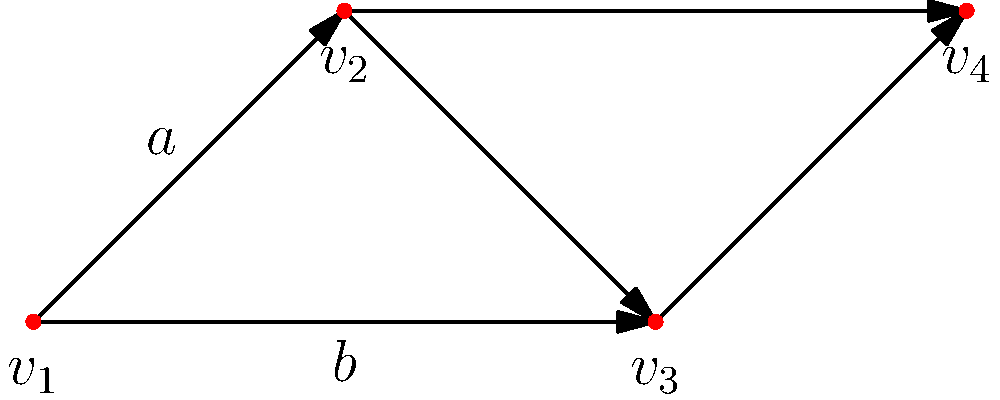Consider the Cayley graph of a neuronal network represented above. If the graph represents a group with two generators $a$ and $b$, what is the order of the group, and what is a possible set of defining relations for this group? To solve this problem, let's follow these steps:

1. Identify the order of the group:
   - The order of a group is the number of elements in the group.
   - In a Cayley graph, each vertex represents a group element.
   - We can see that there are 4 vertices in the graph.
   Therefore, the order of the group is 4.

2. Analyze the generators:
   - We are given that the group has two generators, $a$ and $b$.
   - In the graph, $a$ moves from $v_1$ to $v_2$ and from $v_3$ to $v_4$.
   - $b$ moves from $v_1$ to $v_3$ and from $v_2$ to $v_4$.

3. Determine the relations:
   - We need to find how $a$ and $b$ combine to form the identity element.
   - Moving along $a$ twice brings us back to the starting point, so $a^2 = e$ (identity).
   - Moving along $b$ twice also brings us back, so $b^2 = e$.
   - Moving along $a$ then $b$ is the same as moving along $b$ then $a$, so $ab = ba$.

4. Express the defining relations:
   The defining relations for this group are:
   $$a^2 = e, b^2 = e, ab = ba$$

These relations, along with the two generators, completely define the group structure represented by this Cayley graph.
Answer: Order: 4; Defining relations: $a^2 = e, b^2 = e, ab = ba$ 